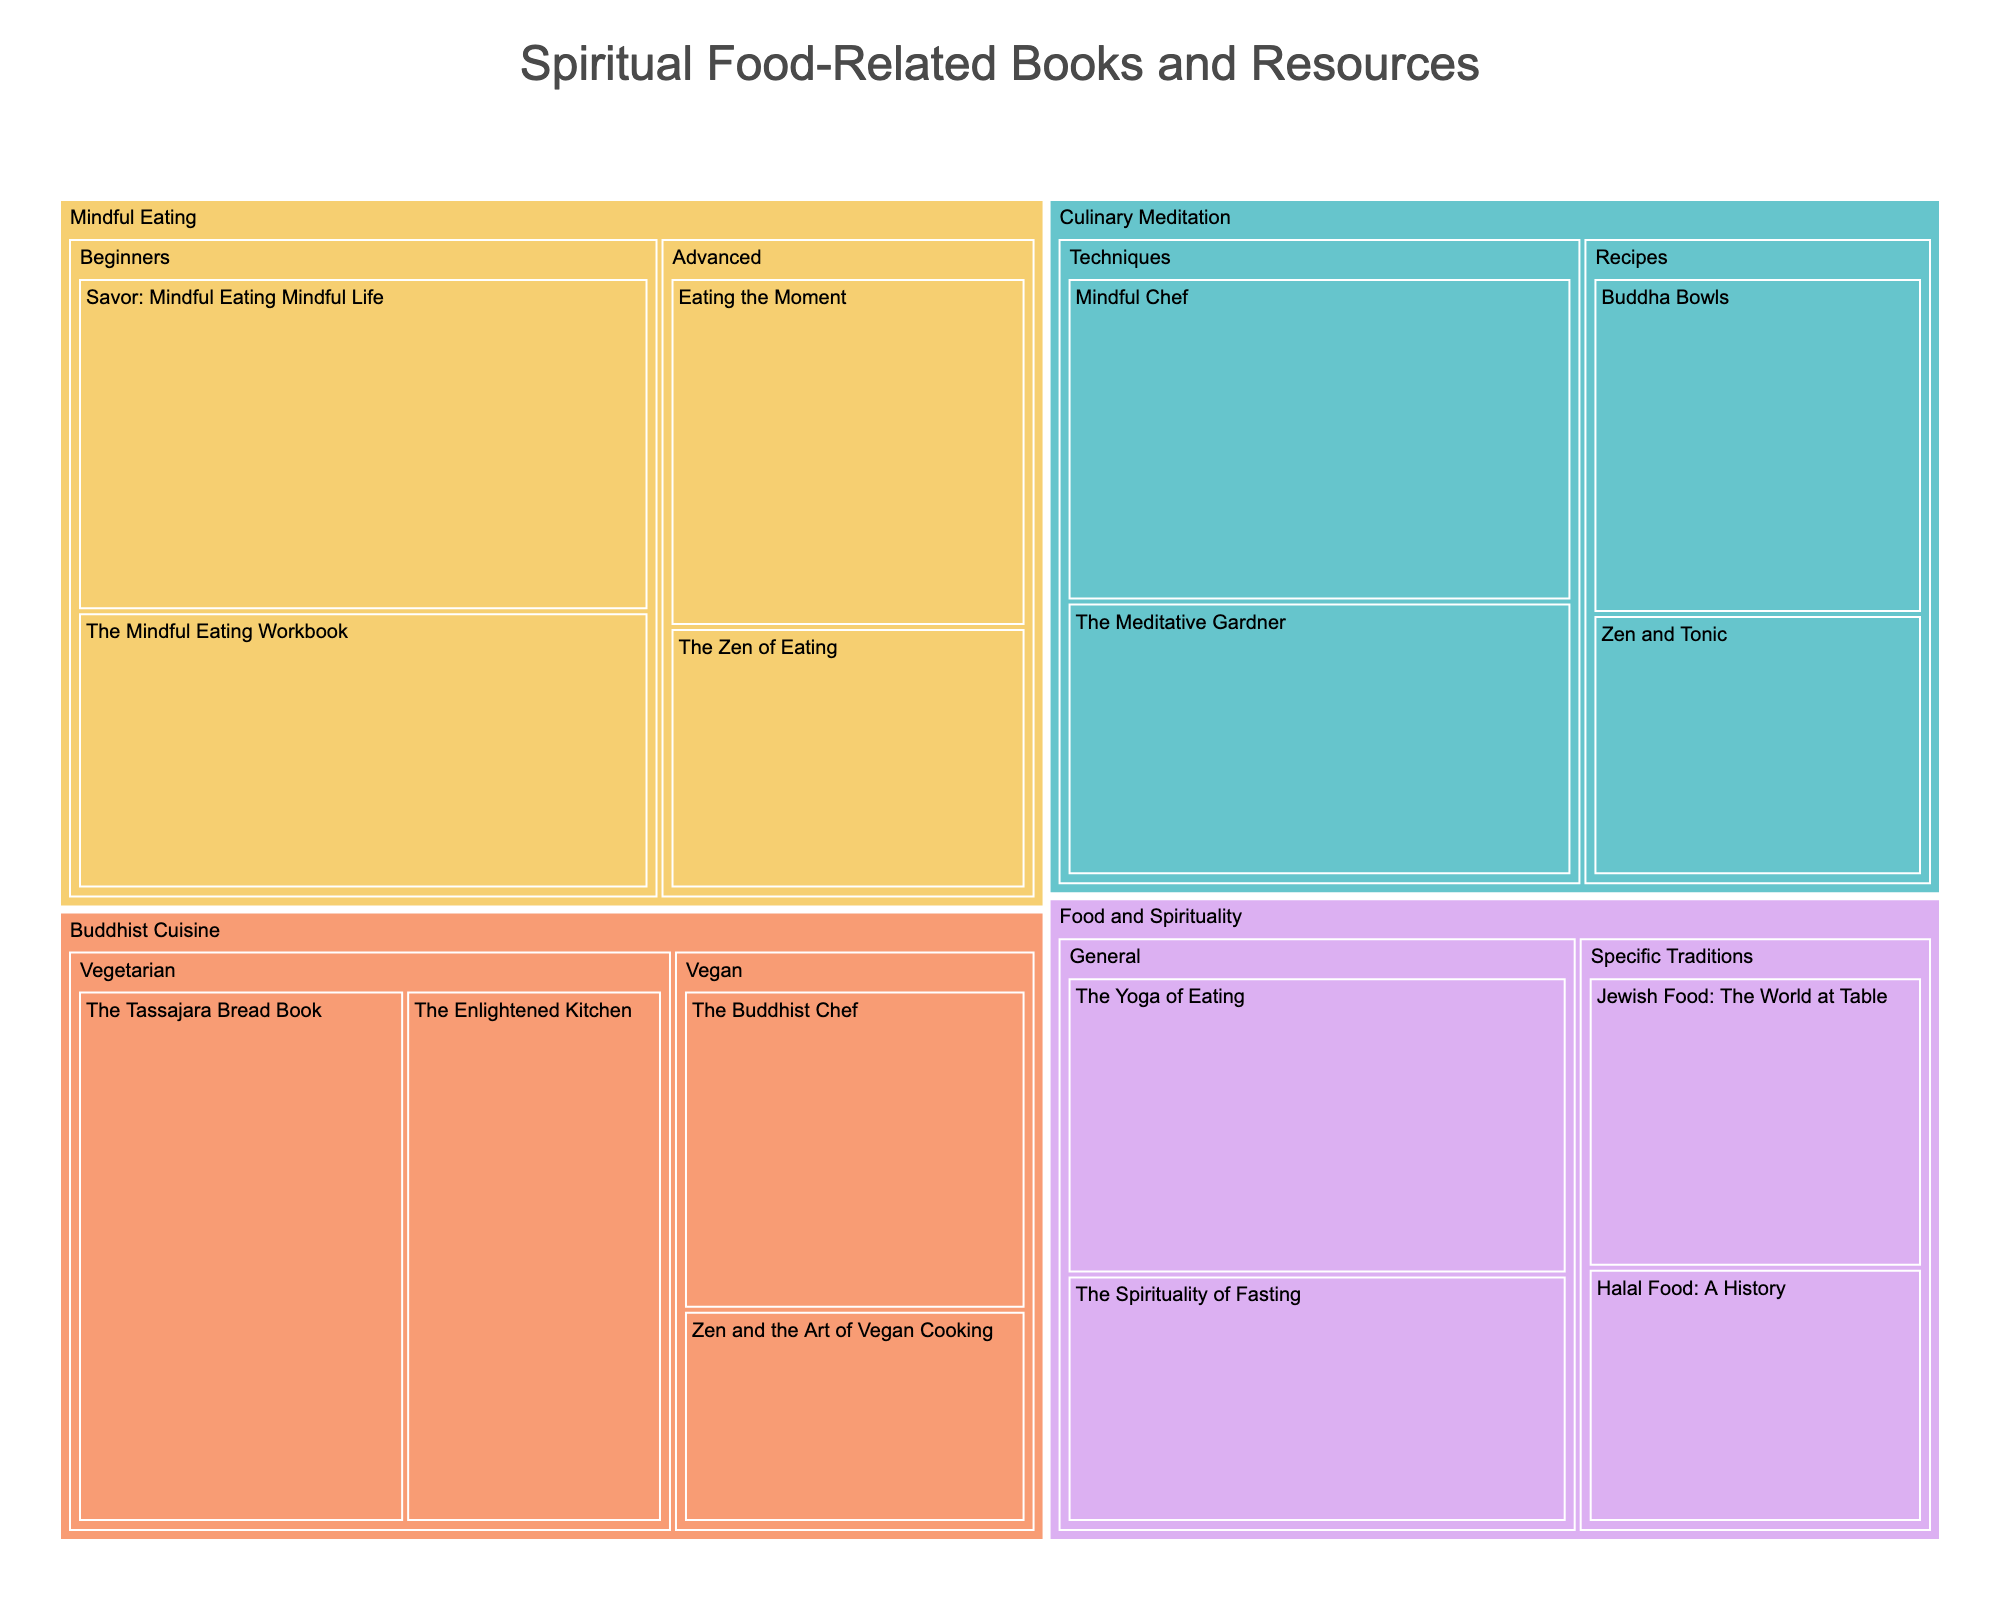What is the title of the treemap? The title of the treemap is displayed at the top of the figure. It summarizes the subject matter of the visualization.
Answer: Spiritual Food-Related Books and Resources How many books/resources are categorized under Mindful Eating for beginners? Locate the Mindful Eating category in the treemap and count the books/resources within the Beginners subcategory. There are two named "Savor: Mindful Eating Mindful Life" and "The Mindful Eating Workbook".
Answer: 2 Which category has the highest value book/resource, and what is it? By scanning the size of the different blocks within each category, you can identify that the largest block is "Savor: Mindful Eating Mindful Life" under Mindful Eating. Its value is 30.
Answer: Mindful Eating, Savor: Mindful Eating Mindful Life What's the total value of the resources under Buddhist Cuisine (Vegetarian and Vegan combined)? Add the values of all resources under the Buddhist Cuisine category, specifically in both the Vegetarian and Vegan subcategories. (28 + 22 + 18 + 12)
Answer: 80 Which subcategory has a higher total value: Culinary Meditation Recipes or Techniques? Sum up the values of resources within each subcategory of Culinary Meditation. Techniques (26 + 22) = 48, Recipes (18 + 14) = 32.
Answer: Techniques Is "Zen and the Art of Vegan Cooking" more popular than "The Buddhist Chef"? Compare the values of "Zen and the Art of Vegan Cooking" and "The Buddhist Chef" under the Vegan subcategory in Buddhist Cuisine. (12 < 18)
Answer: No What is the difference in value between the most and least popular books in the Food and Spirituality category? Find the maximum and minimum values within the Food and Spirituality category. The maximum is 24 (The Yoga of Eating), and the minimum is 14 (Halal Food: A History). Difference is 24 - 14.
Answer: 10 Which has a higher value, "The Meditative Gardner" or "The Tassajara Bread Book"? Compare the values of "The Meditative Gardner" in Culinary Meditation and "The Tassajara Bread Book" in Buddhist Cuisine. (22 < 28)
Answer: The Tassajara Bread Book What percentage of the total value does the vegetarian subcategory of Buddhist Cuisine contribute? Calculate the total values of all books/resources first (30 + 25 + 20 + 15 + 28 + 22 + 18 + 12 + 24 + 20 + 16 + 14 + 26 + 22 + 18 + 14 = 324). Then, divide the value of the Vegetarian subcategory in Buddhist Cuisine (28 + 22 = 50) by the total and multiply by 100. (50 / 324) * 100 ≈ 15.43%
Answer: ≈ 15.43% If a new book is added under the Advanced subcategory of Mindful Eating with a value of 10, what will be the new total value for this subcategory, and how will it affect the category total? Sum the current values of the Advanced subcategory in Mindful Eating (20 + 15), then add the new value (10). For the category total, add this to the existing category total. New subcategory total: 20 + 15 + 10 = 45; new category total: 30 + 25 + 45 = 100.
Answer: Subcategory: 45, Category: 100 